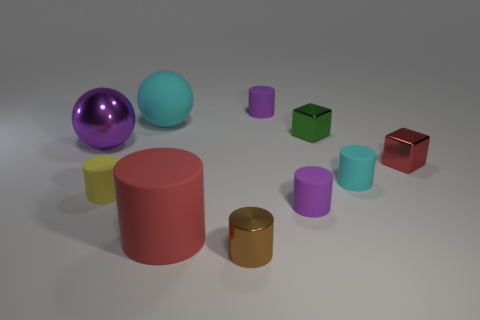Can you describe the textures of the objects in the image? Certainly, the objects in the image display a variety of textures. The purple and cyan spheres exhibit a smooth, reflective surface, indicative of a polished finish. Conversely, the yellow cylinder and small green cube appear to have a matte texture, causing them to reflect less light and seem less shiny. Textural diversity contributes to the image's visual interest. 